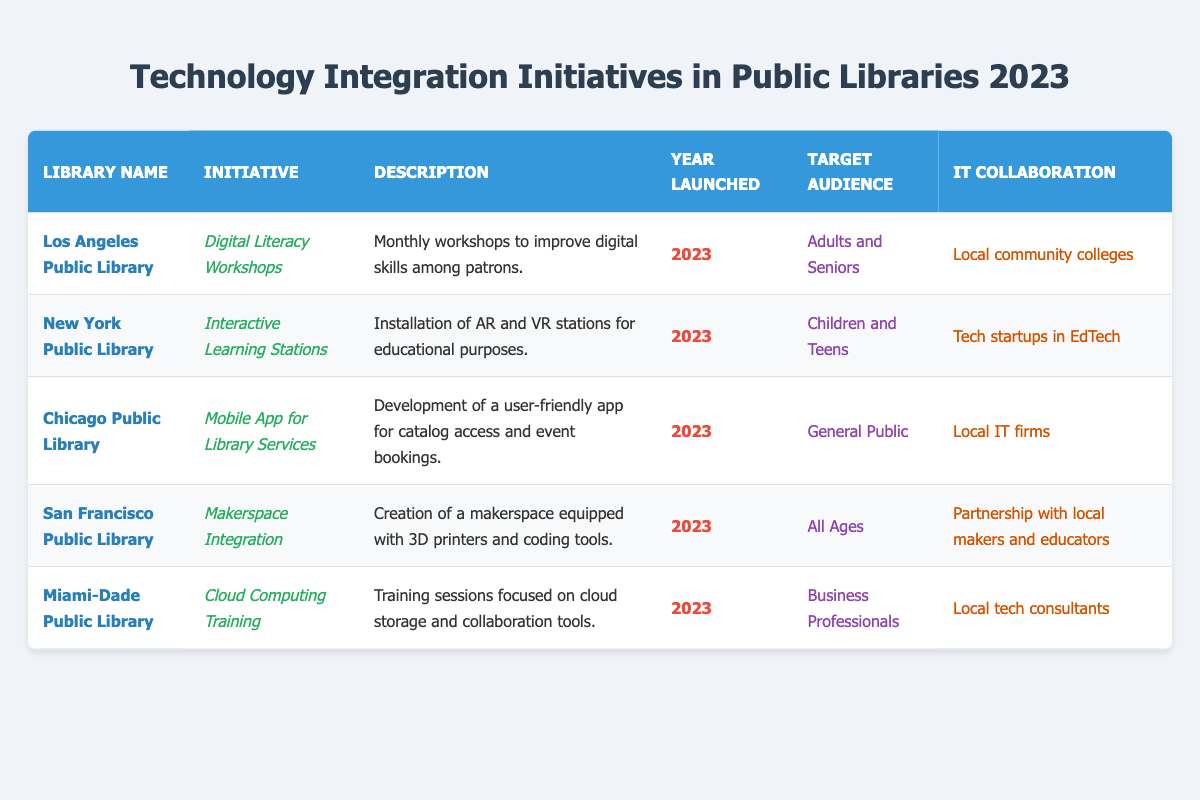What initiative was launched by the Los Angeles Public Library? According to the table, the initiative launched by the Los Angeles Public Library is "Digital Literacy Workshops."
Answer: Digital Literacy Workshops Which library's initiative targets Business Professionals? The Miami-Dade Public Library's initiative targets Business Professionals, specifically through "Cloud Computing Training."
Answer: Miami-Dade Public Library How many initiatives target children or teens? Two initiatives target children or teens: the New York Public Library's "Interactive Learning Stations" and the San Francisco Public Library's "Makerspace Integration."
Answer: 2 Is there an initiative that collaborated with local tech consultants? Yes, the Miami-Dade Public Library's initiative, "Cloud Computing Training," collaborates with local tech consultants.
Answer: Yes Which library's initiative involves the use of AR and VR technology? The New York Public Library's initiative, "Interactive Learning Stations," involves the installation of AR and VR stations for educational purposes.
Answer: New York Public Library List the target audiences for all initiatives launched in 2023. The target audiences are as follows: Adults and Seniors (Los Angeles), Children and Teens (New York), General Public (Chicago), All Ages (San Francisco), and Business Professionals (Miami-Dade).
Answer: Adults and Seniors, Children and Teens, General Public, All Ages, Business Professionals Which library has an initiative focused on general public access? The Chicago Public Library has an initiative ("Mobile App for Library Services") focused on general public access through its app development.
Answer: Chicago Public Library What is the difference in the target audience between the "Makerspace Integration" and "Digital Literacy Workshops"? "Makerspace Integration" targets all ages, while "Digital Literacy Workshops" specifically targets adults and seniors. The difference is that one is inclusive of all ages, whereas the other is specific to adults and seniors.
Answer: All Ages vs. Adults and Seniors How many of the initiatives are intended for all ages? Only one initiative, "Makerspace Integration" from the San Francisco Public Library, is intended for all ages.
Answer: 1 